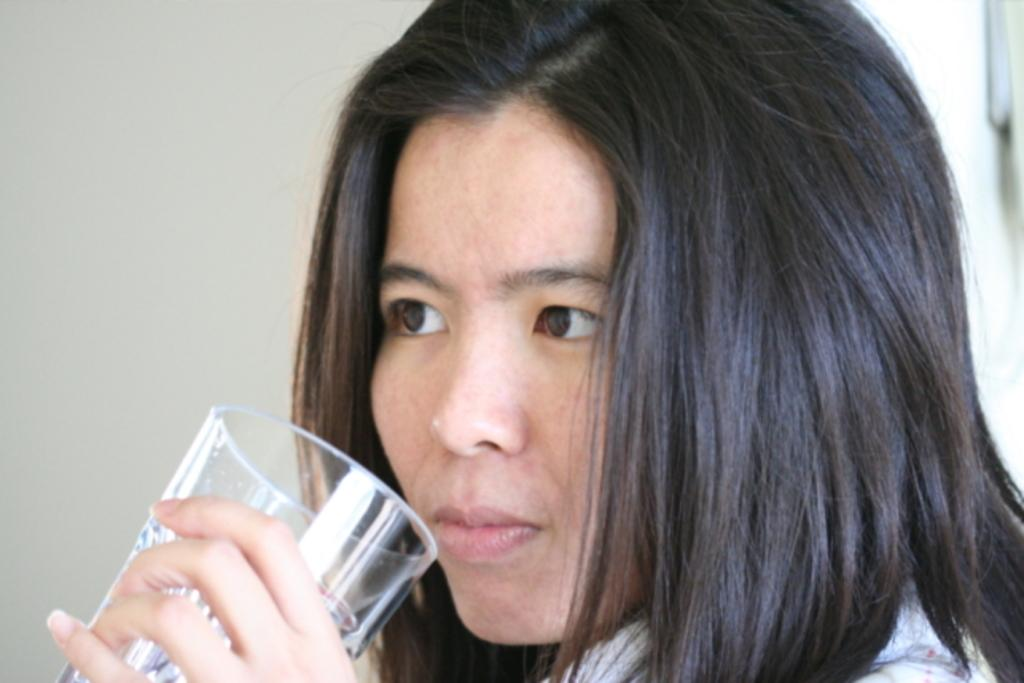Who is present in the image? There is a woman in the image. What is the woman holding in the image? The woman is holding a glass. What can be seen in the background of the image? There is a wall in the background of the image. What type of pump is visible in the image? There is no pump present in the image. What kind of business is being conducted in the image? The image does not depict any business activities. 